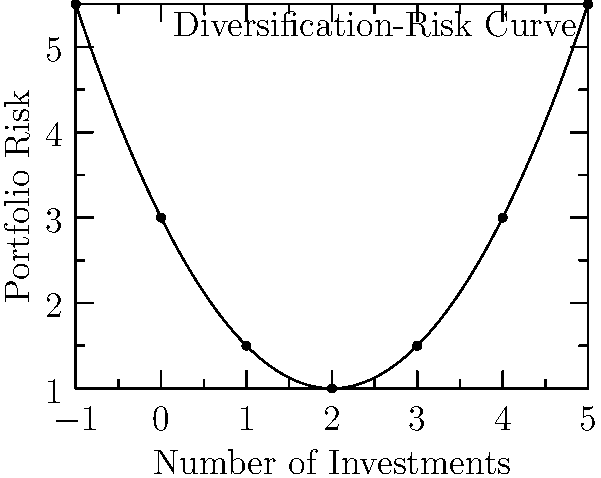The graph represents the relationship between the number of investments (diversification) and portfolio risk for a non-tech industry portfolio. The curve can be modeled by the quadratic function $f(x) = 0.5x^2 - 2x + 3$, where $x$ is the number of investments and $f(x)$ is the portfolio risk. Find the coordinates of the vertex of this parabola, which represents the point of minimum risk. To find the vertex of the parabola, we can follow these steps:

1) For a quadratic function in the form $f(x) = ax^2 + bx + c$, the x-coordinate of the vertex is given by $x = -\frac{b}{2a}$.

2) In our function $f(x) = 0.5x^2 - 2x + 3$:
   $a = 0.5$
   $b = -2$
   $c = 3$

3) Calculating the x-coordinate:
   $x = -\frac{b}{2a} = -\frac{-2}{2(0.5)} = -\frac{-2}{1} = 2$

4) To find the y-coordinate, we substitute $x = 2$ into the original function:
   $f(2) = 0.5(2)^2 - 2(2) + 3$
         $= 0.5(4) - 4 + 3$
         $= 2 - 4 + 3$
         $= 1$

5) Therefore, the vertex of the parabola is at the point (2, 1).

This point represents the optimal number of investments (2) to achieve the minimum portfolio risk (1) in this non-tech industry portfolio.
Answer: (2, 1) 